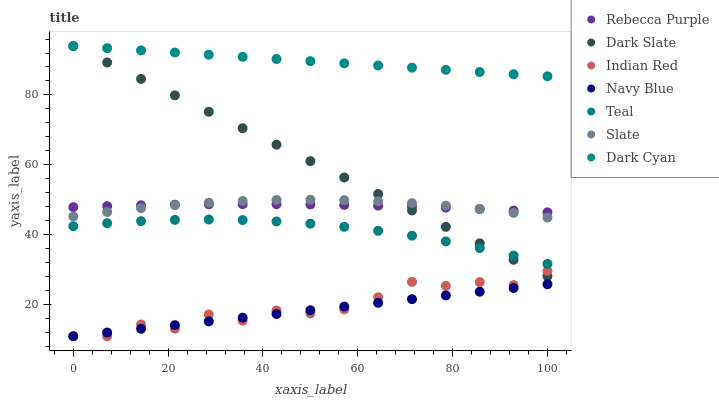Does Navy Blue have the minimum area under the curve?
Answer yes or no. Yes. Does Dark Cyan have the maximum area under the curve?
Answer yes or no. Yes. Does Slate have the minimum area under the curve?
Answer yes or no. No. Does Slate have the maximum area under the curve?
Answer yes or no. No. Is Navy Blue the smoothest?
Answer yes or no. Yes. Is Indian Red the roughest?
Answer yes or no. Yes. Is Slate the smoothest?
Answer yes or no. No. Is Slate the roughest?
Answer yes or no. No. Does Indian Red have the lowest value?
Answer yes or no. Yes. Does Slate have the lowest value?
Answer yes or no. No. Does Dark Cyan have the highest value?
Answer yes or no. Yes. Does Slate have the highest value?
Answer yes or no. No. Is Navy Blue less than Teal?
Answer yes or no. Yes. Is Dark Cyan greater than Navy Blue?
Answer yes or no. Yes. Does Dark Slate intersect Dark Cyan?
Answer yes or no. Yes. Is Dark Slate less than Dark Cyan?
Answer yes or no. No. Is Dark Slate greater than Dark Cyan?
Answer yes or no. No. Does Navy Blue intersect Teal?
Answer yes or no. No. 